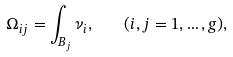<formula> <loc_0><loc_0><loc_500><loc_500>\Omega _ { i j } = \int _ { B _ { j } } \nu _ { i } , \quad ( i , j = 1 , \dots , g ) ,</formula> 